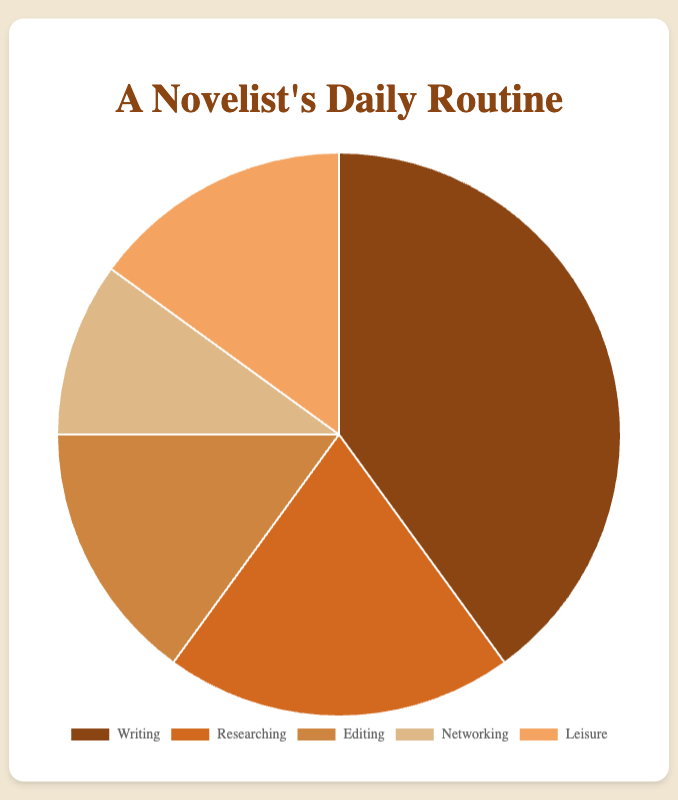Which activity takes up the largest portion of a novelist's daily routine? Writing occupies 40% of the total time, which is the largest proportion among all activities.
Answer: Writing What is the total percentage of time spent on Editing and Leisure combined? Editing takes 15% and Leisure takes another 15%. Adding these two percentages gives us 15 + 15 = 30%.
Answer: 30% How does the time allocated to Researching compare to the time allocated to Networking? Researching takes up 20% of the time whereas Networking takes up 10%. Clearly, Researching occupies twice as much time as Networking.
Answer: Researching takes twice as much time as Networking What percentage of time is spent on activities other than Writing? Writing takes up 40% of the time, leaving 100 - 40 = 60% of the time for other activities.
Answer: 60% If a novelist decided to increase their Networking time by 5%, from which activity should the 5% be subtracted to keep the total percentage at 100 without affecting Writing time? Removing 5% from the combined time of Researching (20%), Editing (15%), and Leisure (15%), totaling 50%. We could subtract 5% from either Researching, Editing, or Leisure, as long as Writing's 40% remains unchanged. The choice could depend on the novelist's preference.
Answer: From Researching, Editing, or Leisure Which activities have an equal amount of time allocation? Both Editing and Leisure have 15% of time allocation each.
Answer: Editing and Leisure If Networking time is represented by a light brown color, which activity is colored darkest? Networking is light brown, and Writing, with the highest percentage, is represented by the darkest color.
Answer: Writing What is the ratio of time spent Writing to time spent Researching? Writing occupies 40% while Researching takes 20%. Therefore, the ratio of time spent Writing to Researching is 40:20, which simplifies to 2:1.
Answer: 2:1 What is the average percentage of time spent per activity? Summing the percentages: 40% (Writing) + 20% (Researching) + 15% (Editing) + 10% (Networking) + 15% (Leisure) = 100%. Dividing by 5 activities gives an average time of 100 / 5 = 20%.
Answer: 20% By what percentage does the time spent on Networking and Writing differ? Writing occupies 40% and Networking takes 10%. The difference is 40% - 10% = 30%.
Answer: 30% 